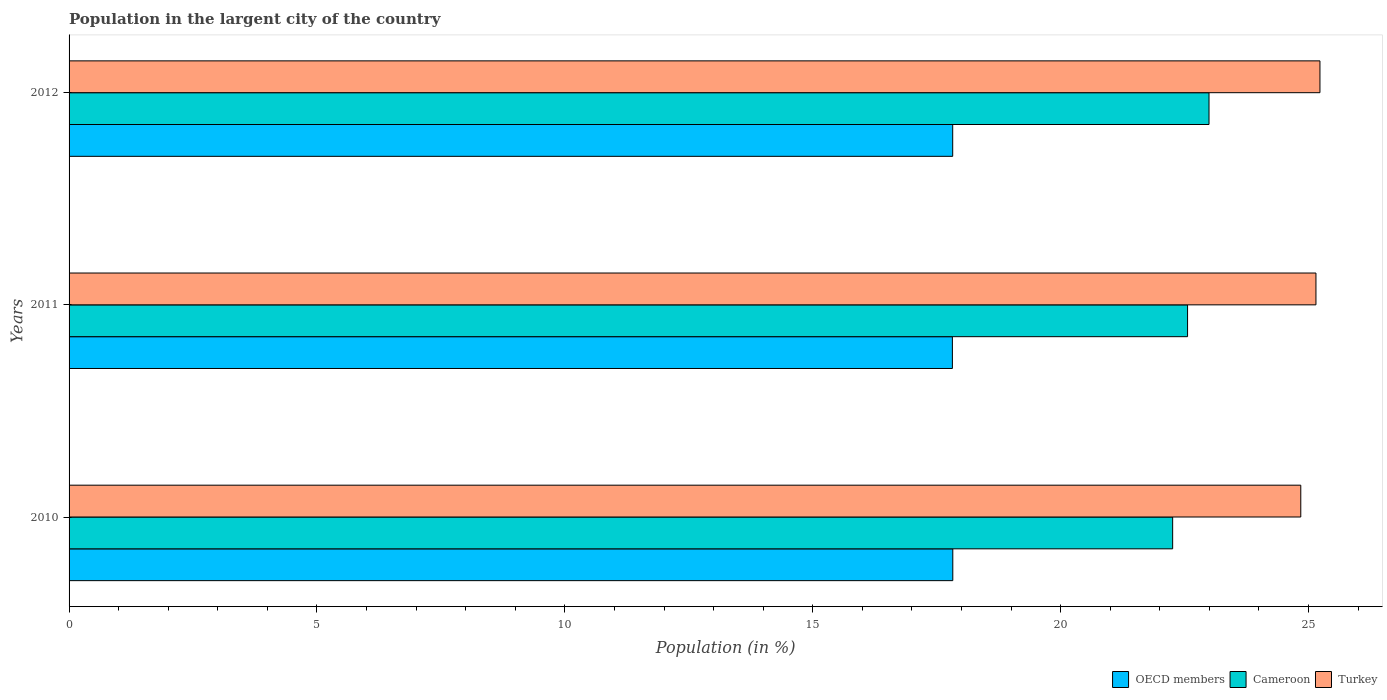How many different coloured bars are there?
Make the answer very short. 3. Are the number of bars per tick equal to the number of legend labels?
Give a very brief answer. Yes. Are the number of bars on each tick of the Y-axis equal?
Your answer should be compact. Yes. How many bars are there on the 1st tick from the bottom?
Ensure brevity in your answer.  3. What is the percentage of population in the largent city in OECD members in 2012?
Ensure brevity in your answer.  17.82. Across all years, what is the maximum percentage of population in the largent city in Turkey?
Offer a very short reply. 25.23. Across all years, what is the minimum percentage of population in the largent city in Turkey?
Make the answer very short. 24.84. What is the total percentage of population in the largent city in OECD members in the graph?
Make the answer very short. 53.46. What is the difference between the percentage of population in the largent city in Turkey in 2010 and that in 2012?
Your answer should be very brief. -0.39. What is the difference between the percentage of population in the largent city in OECD members in 2011 and the percentage of population in the largent city in Turkey in 2012?
Give a very brief answer. -7.41. What is the average percentage of population in the largent city in OECD members per year?
Keep it short and to the point. 17.82. In the year 2010, what is the difference between the percentage of population in the largent city in Cameroon and percentage of population in the largent city in Turkey?
Your answer should be very brief. -2.58. In how many years, is the percentage of population in the largent city in OECD members greater than 19 %?
Your answer should be very brief. 0. What is the ratio of the percentage of population in the largent city in Cameroon in 2010 to that in 2012?
Keep it short and to the point. 0.97. Is the percentage of population in the largent city in Turkey in 2011 less than that in 2012?
Make the answer very short. Yes. Is the difference between the percentage of population in the largent city in Cameroon in 2011 and 2012 greater than the difference between the percentage of population in the largent city in Turkey in 2011 and 2012?
Offer a terse response. No. What is the difference between the highest and the second highest percentage of population in the largent city in Turkey?
Your answer should be compact. 0.08. What is the difference between the highest and the lowest percentage of population in the largent city in Cameroon?
Offer a very short reply. 0.73. What does the 2nd bar from the top in 2012 represents?
Keep it short and to the point. Cameroon. Is it the case that in every year, the sum of the percentage of population in the largent city in Cameroon and percentage of population in the largent city in Turkey is greater than the percentage of population in the largent city in OECD members?
Make the answer very short. Yes. How many bars are there?
Your answer should be very brief. 9. How many years are there in the graph?
Provide a short and direct response. 3. What is the difference between two consecutive major ticks on the X-axis?
Provide a short and direct response. 5. Are the values on the major ticks of X-axis written in scientific E-notation?
Keep it short and to the point. No. Does the graph contain any zero values?
Your answer should be compact. No. What is the title of the graph?
Provide a short and direct response. Population in the largent city of the country. Does "Ethiopia" appear as one of the legend labels in the graph?
Provide a succinct answer. No. What is the label or title of the X-axis?
Your answer should be compact. Population (in %). What is the Population (in %) in OECD members in 2010?
Offer a terse response. 17.82. What is the Population (in %) of Cameroon in 2010?
Offer a very short reply. 22.26. What is the Population (in %) in Turkey in 2010?
Make the answer very short. 24.84. What is the Population (in %) in OECD members in 2011?
Provide a short and direct response. 17.82. What is the Population (in %) in Cameroon in 2011?
Give a very brief answer. 22.56. What is the Population (in %) of Turkey in 2011?
Make the answer very short. 25.15. What is the Population (in %) of OECD members in 2012?
Your answer should be very brief. 17.82. What is the Population (in %) in Cameroon in 2012?
Offer a very short reply. 22.99. What is the Population (in %) in Turkey in 2012?
Your response must be concise. 25.23. Across all years, what is the maximum Population (in %) of OECD members?
Provide a succinct answer. 17.82. Across all years, what is the maximum Population (in %) of Cameroon?
Ensure brevity in your answer.  22.99. Across all years, what is the maximum Population (in %) of Turkey?
Offer a very short reply. 25.23. Across all years, what is the minimum Population (in %) of OECD members?
Give a very brief answer. 17.82. Across all years, what is the minimum Population (in %) in Cameroon?
Make the answer very short. 22.26. Across all years, what is the minimum Population (in %) in Turkey?
Provide a short and direct response. 24.84. What is the total Population (in %) in OECD members in the graph?
Ensure brevity in your answer.  53.46. What is the total Population (in %) of Cameroon in the graph?
Your response must be concise. 67.81. What is the total Population (in %) in Turkey in the graph?
Ensure brevity in your answer.  75.22. What is the difference between the Population (in %) of OECD members in 2010 and that in 2011?
Provide a short and direct response. 0.01. What is the difference between the Population (in %) in Cameroon in 2010 and that in 2011?
Your answer should be very brief. -0.3. What is the difference between the Population (in %) of Turkey in 2010 and that in 2011?
Keep it short and to the point. -0.31. What is the difference between the Population (in %) in OECD members in 2010 and that in 2012?
Provide a succinct answer. 0. What is the difference between the Population (in %) in Cameroon in 2010 and that in 2012?
Keep it short and to the point. -0.73. What is the difference between the Population (in %) in Turkey in 2010 and that in 2012?
Provide a short and direct response. -0.39. What is the difference between the Population (in %) in OECD members in 2011 and that in 2012?
Your response must be concise. -0.01. What is the difference between the Population (in %) in Cameroon in 2011 and that in 2012?
Keep it short and to the point. -0.43. What is the difference between the Population (in %) in Turkey in 2011 and that in 2012?
Your response must be concise. -0.08. What is the difference between the Population (in %) in OECD members in 2010 and the Population (in %) in Cameroon in 2011?
Offer a terse response. -4.74. What is the difference between the Population (in %) of OECD members in 2010 and the Population (in %) of Turkey in 2011?
Your response must be concise. -7.32. What is the difference between the Population (in %) of Cameroon in 2010 and the Population (in %) of Turkey in 2011?
Make the answer very short. -2.89. What is the difference between the Population (in %) of OECD members in 2010 and the Population (in %) of Cameroon in 2012?
Make the answer very short. -5.17. What is the difference between the Population (in %) of OECD members in 2010 and the Population (in %) of Turkey in 2012?
Provide a short and direct response. -7.41. What is the difference between the Population (in %) in Cameroon in 2010 and the Population (in %) in Turkey in 2012?
Give a very brief answer. -2.97. What is the difference between the Population (in %) in OECD members in 2011 and the Population (in %) in Cameroon in 2012?
Offer a terse response. -5.18. What is the difference between the Population (in %) in OECD members in 2011 and the Population (in %) in Turkey in 2012?
Offer a terse response. -7.41. What is the difference between the Population (in %) in Cameroon in 2011 and the Population (in %) in Turkey in 2012?
Provide a succinct answer. -2.67. What is the average Population (in %) in OECD members per year?
Keep it short and to the point. 17.82. What is the average Population (in %) in Cameroon per year?
Keep it short and to the point. 22.6. What is the average Population (in %) in Turkey per year?
Ensure brevity in your answer.  25.07. In the year 2010, what is the difference between the Population (in %) in OECD members and Population (in %) in Cameroon?
Provide a succinct answer. -4.43. In the year 2010, what is the difference between the Population (in %) in OECD members and Population (in %) in Turkey?
Keep it short and to the point. -7.02. In the year 2010, what is the difference between the Population (in %) of Cameroon and Population (in %) of Turkey?
Your answer should be very brief. -2.58. In the year 2011, what is the difference between the Population (in %) of OECD members and Population (in %) of Cameroon?
Your answer should be compact. -4.74. In the year 2011, what is the difference between the Population (in %) of OECD members and Population (in %) of Turkey?
Provide a succinct answer. -7.33. In the year 2011, what is the difference between the Population (in %) in Cameroon and Population (in %) in Turkey?
Offer a very short reply. -2.59. In the year 2012, what is the difference between the Population (in %) of OECD members and Population (in %) of Cameroon?
Provide a short and direct response. -5.17. In the year 2012, what is the difference between the Population (in %) of OECD members and Population (in %) of Turkey?
Your answer should be very brief. -7.41. In the year 2012, what is the difference between the Population (in %) of Cameroon and Population (in %) of Turkey?
Your answer should be very brief. -2.24. What is the ratio of the Population (in %) in OECD members in 2010 to that in 2011?
Give a very brief answer. 1. What is the ratio of the Population (in %) in Cameroon in 2010 to that in 2011?
Your response must be concise. 0.99. What is the ratio of the Population (in %) of OECD members in 2010 to that in 2012?
Make the answer very short. 1. What is the ratio of the Population (in %) in Cameroon in 2010 to that in 2012?
Ensure brevity in your answer.  0.97. What is the ratio of the Population (in %) of Turkey in 2010 to that in 2012?
Your answer should be very brief. 0.98. What is the ratio of the Population (in %) of OECD members in 2011 to that in 2012?
Offer a very short reply. 1. What is the ratio of the Population (in %) of Cameroon in 2011 to that in 2012?
Offer a very short reply. 0.98. What is the difference between the highest and the second highest Population (in %) of OECD members?
Keep it short and to the point. 0. What is the difference between the highest and the second highest Population (in %) in Cameroon?
Offer a very short reply. 0.43. What is the difference between the highest and the second highest Population (in %) in Turkey?
Provide a short and direct response. 0.08. What is the difference between the highest and the lowest Population (in %) in OECD members?
Your answer should be compact. 0.01. What is the difference between the highest and the lowest Population (in %) in Cameroon?
Your answer should be compact. 0.73. What is the difference between the highest and the lowest Population (in %) of Turkey?
Offer a terse response. 0.39. 